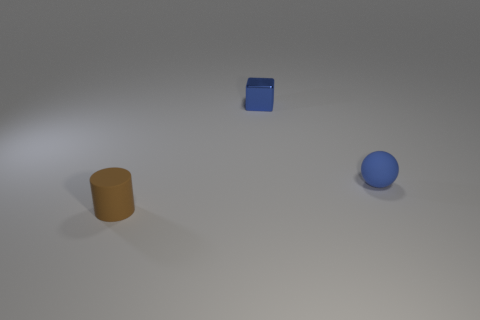What size is the sphere?
Provide a short and direct response. Small. Is the number of tiny blue rubber things that are in front of the matte cylinder greater than the number of brown rubber things?
Give a very brief answer. No. Are there the same number of things in front of the blue sphere and metal objects that are left of the small brown rubber cylinder?
Keep it short and to the point. No. The tiny thing that is both to the left of the tiny sphere and in front of the blue block is what color?
Your answer should be very brief. Brown. Are there more small brown objects to the left of the matte sphere than matte objects that are behind the tiny block?
Your answer should be compact. Yes. Do the thing to the right of the metal cube and the tiny blue cube have the same size?
Provide a succinct answer. Yes. There is a matte object that is in front of the tiny matte object that is right of the metallic object; how many tiny objects are on the right side of it?
Keep it short and to the point. 2. What number of other objects are the same shape as the metallic thing?
Offer a very short reply. 0. There is a blue rubber sphere; how many tiny blue blocks are behind it?
Keep it short and to the point. 1. Are there fewer blocks to the right of the tiny brown matte cylinder than tiny spheres behind the small matte sphere?
Your answer should be very brief. No. 